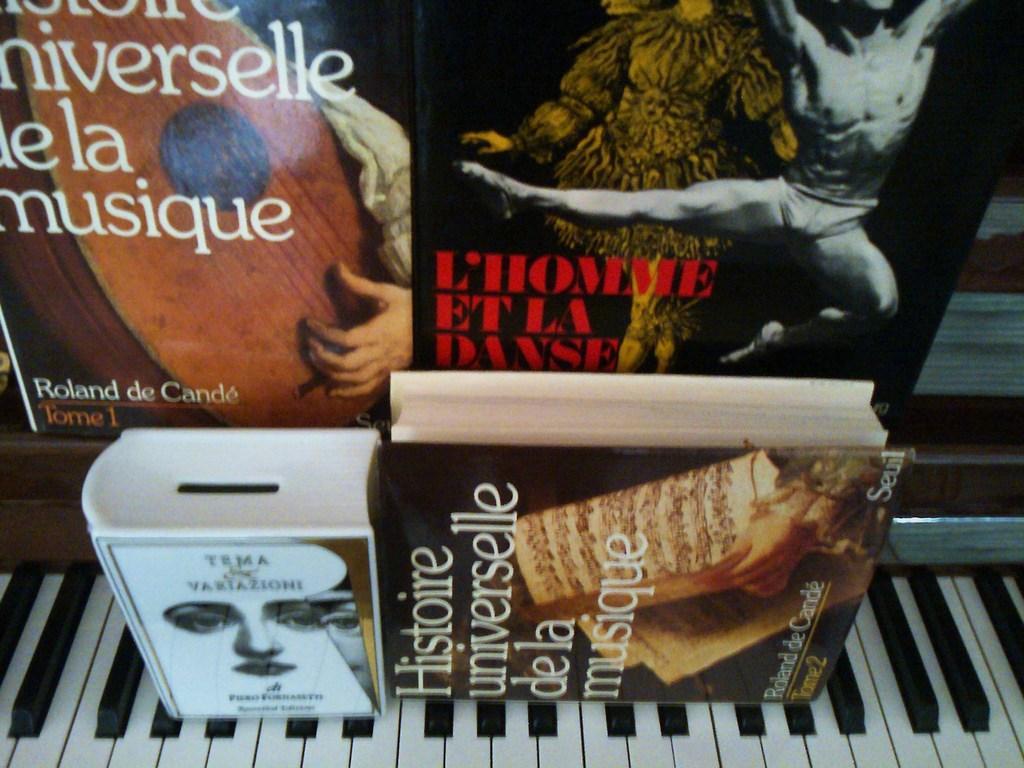Can you describe this image briefly? In this image we can see a piano, box, book, and posters. On the posters we can see picture of a person and text written on it. 